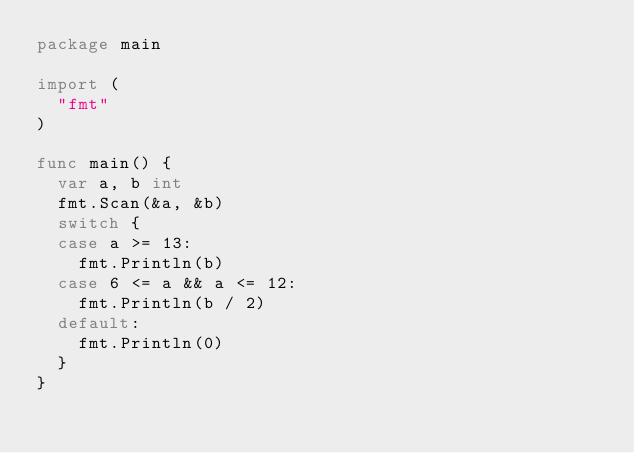Convert code to text. <code><loc_0><loc_0><loc_500><loc_500><_Go_>package main

import (
	"fmt"
)

func main() {
	var a, b int
	fmt.Scan(&a, &b)
	switch {
	case a >= 13:
		fmt.Println(b)
	case 6 <= a && a <= 12:
		fmt.Println(b / 2)
	default:
		fmt.Println(0)
	}
}
</code> 